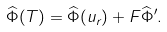<formula> <loc_0><loc_0><loc_500><loc_500>\widehat { \Phi } ( T ) = \widehat { \Phi } ( u _ { r } ) + F \widehat { \Phi } ^ { \prime } .</formula> 